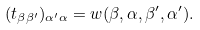Convert formula to latex. <formula><loc_0><loc_0><loc_500><loc_500>( t _ { \beta \beta ^ { \prime } } ) _ { \alpha ^ { \prime } \alpha } = w ( \beta , \alpha , \beta ^ { \prime } , \alpha ^ { \prime } ) .</formula> 